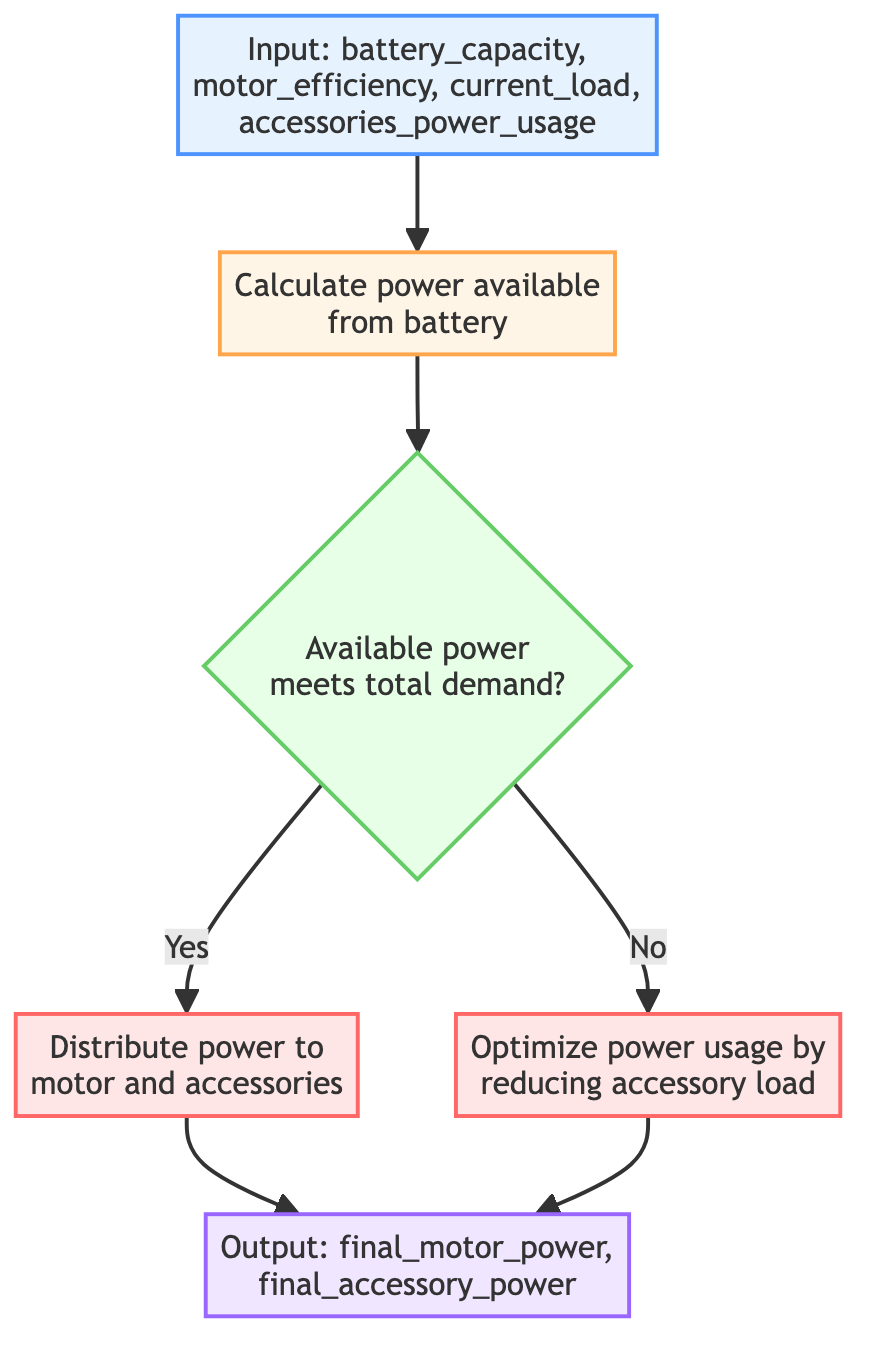What are the input parameters for this function? The function takes four input parameters: battery_capacity, motor_efficiency, current_load, and accessories_power_usage. These parameters are represented in the first node labeled "Input".
Answer: battery_capacity, motor_efficiency, current_load, accessories_power_usage What is the output of the function? The output of the function consists of two parameters listed in the last node labeled "Output": final_motor_power and final_accessory_power.
Answer: final_motor_power, final_accessory_power How many steps are in the flowchart? The flowchart has 6 steps: 1 Input, 1 Calculation, 1 Decision, 2 Actions, and 1 Output. This counts each node depicted in the diagram as a step.
Answer: 6 What happens if the available power does not meet total demand? If the available power does not meet the total demand, the flowchart directs to Step 4, which focuses on optimizing power usage by reducing accessory load. This is indicated by the "No" output from the decision node.
Answer: Optimize power usage by reducing accessory load Which step calculates the power available from the battery? Step 1, labeled "Calculate power available from battery", is responsible for this calculation using the input parameters: battery_capacity, motor_efficiency, and current_load.
Answer: Calculate power available from battery What decision does the flowchart make after calculating the available power? The flowchart examines whether the available power meets the total demand, which consists of accessories_power_usage plus current_load. This is shown in the decision node labeled "Available power meets total demand?".
Answer: Available power meets total demand? What actions are taken when available power is sufficient? When the available power is sufficient, Step 3 is executed, which distributes power to both the motor and accessories based on the available_power, motor_efficiency, and accessories_power_usage. This process is shown in the "Yes" output from the decision node.
Answer: Distribute power to motor and accessories Which element in the diagram checks if the available power is adequate? The element that checks if the available power is adequate is labeled as "Available power meets total demand?" and is represented as a decision node in the flowchart, with conditional paths leading to subsequent actions based on the result.
Answer: Available power meets total demand? What is the purpose of Step 4 in the flowchart? Step 4, labeled "Optimize power usage by reducing accessory load", aims to ensure that the total power consumption remains manageable when the available power is insufficient. This instruction indicates a strategy to mitigate accessory power demand.
Answer: Optimize power usage by reducing accessory load 